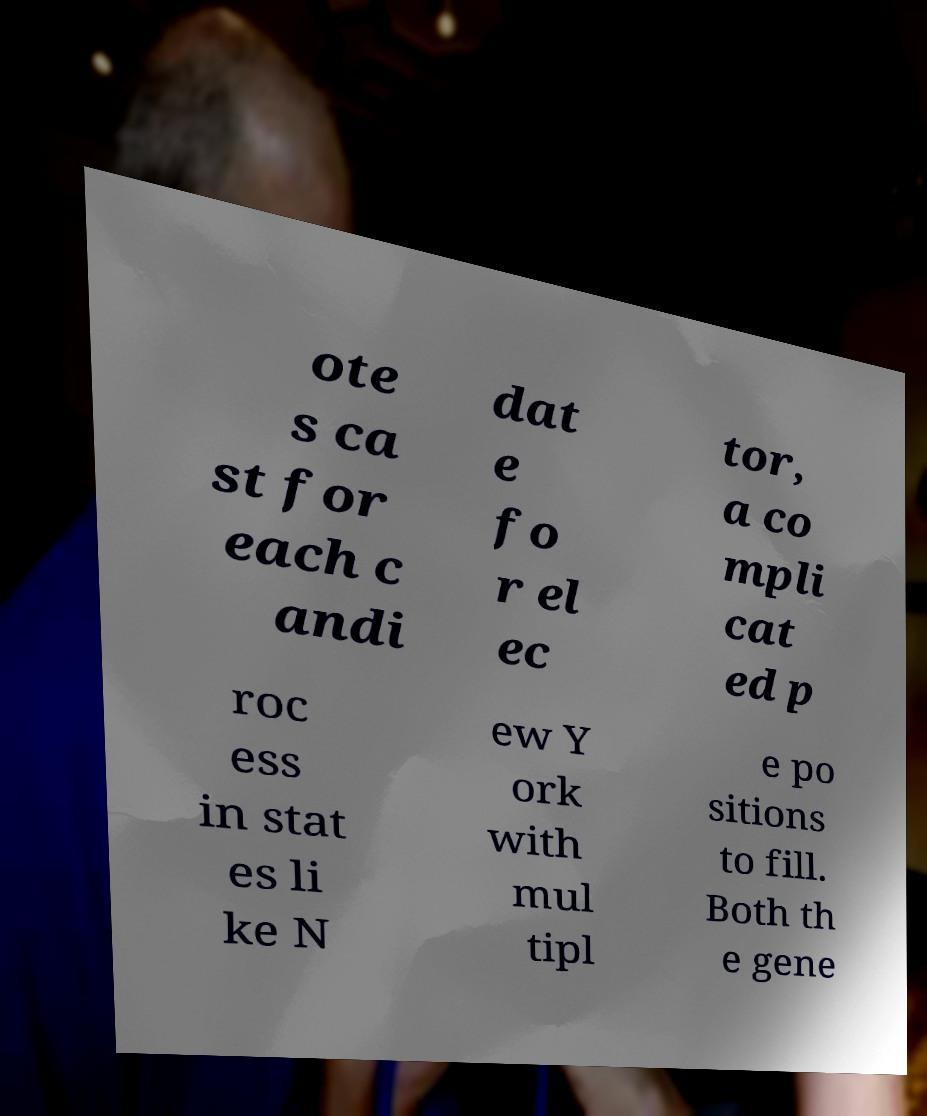Can you accurately transcribe the text from the provided image for me? ote s ca st for each c andi dat e fo r el ec tor, a co mpli cat ed p roc ess in stat es li ke N ew Y ork with mul tipl e po sitions to fill. Both th e gene 